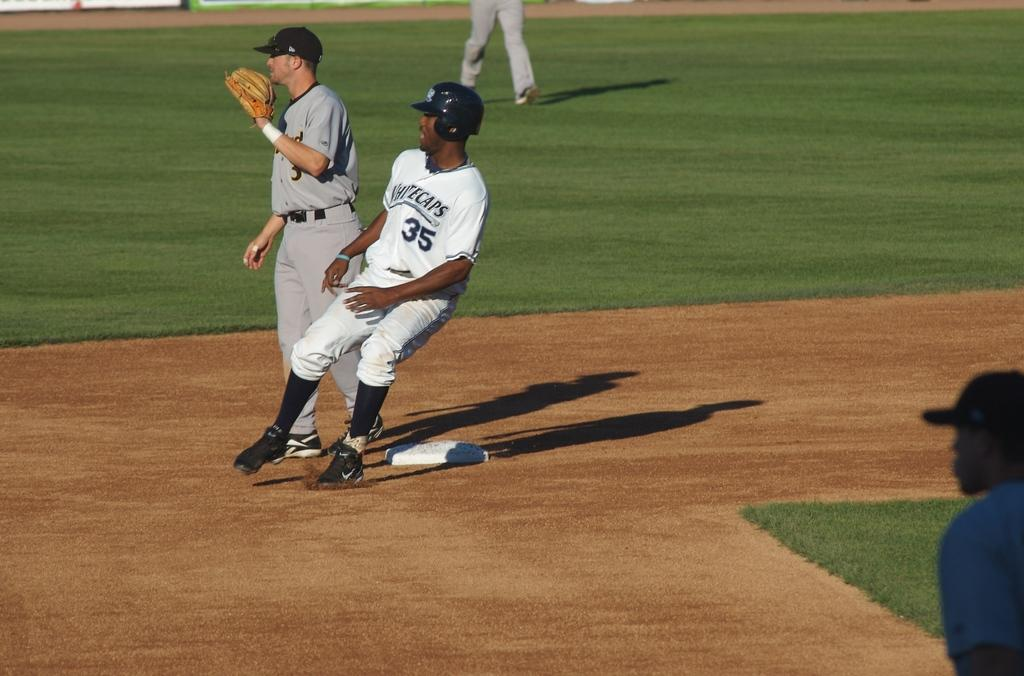<image>
Write a terse but informative summary of the picture. Whitecaps baseball player number 35 attempts to steal a base. 